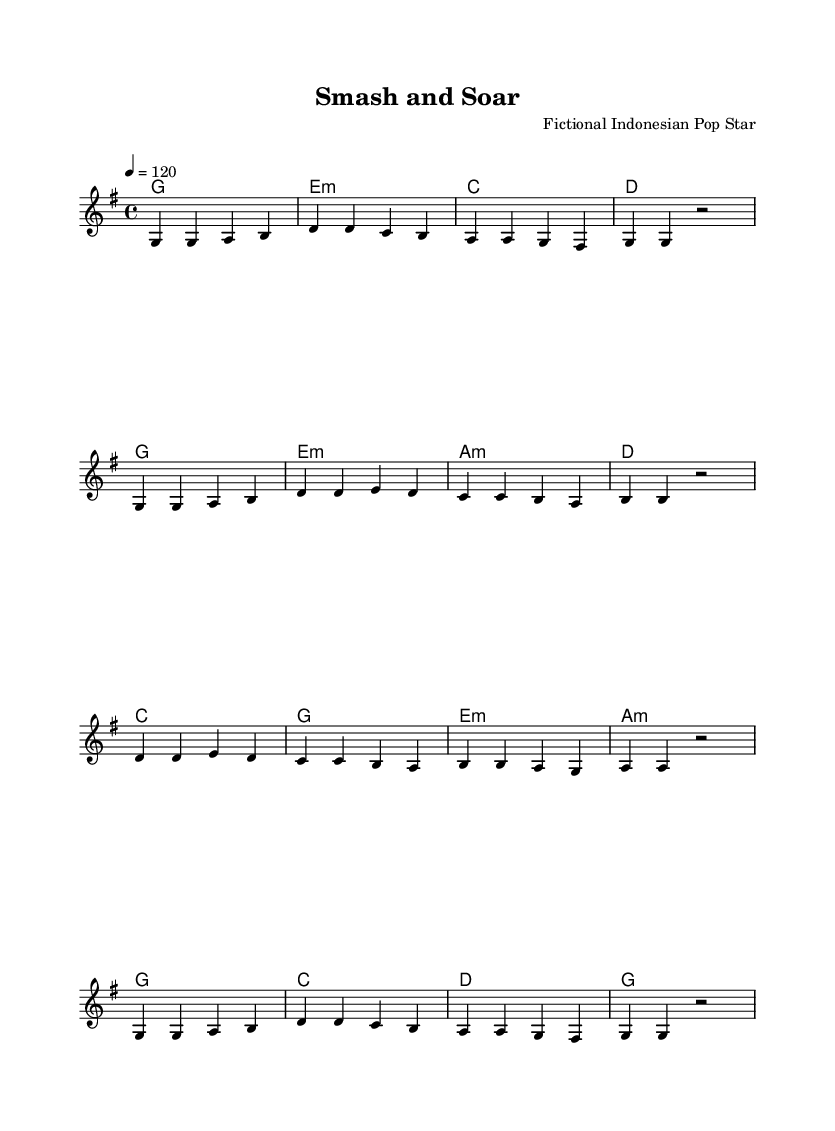What is the key signature of this music? The key signature is G major, which has one sharp (F#). This is determined by looking at the key signature indicated at the beginning of the sheet music.
Answer: G major What is the time signature of this music? The time signature is 4/4, as noted at the beginning of the sheet music right next to the key signature. This means there are four beats in each measure, and the quarter note gets one beat.
Answer: 4/4 What is the tempo of this piece? The tempo is 120 beats per minute, indicated at the beginning of the score under the global settings for tempo. This means the piece is intended to be played at a moderate speed.
Answer: 120 How many measures are in the melody? There are 12 measures in the melody section of the sheet music. This can be counted by looking at the grouping of notes and spaces, where each measure is separated by a vertical line.
Answer: 12 What chord is played in the first measure? The chord played in the first measure is G major, noted at the beginning of the chord progressions in the score. This can be identified by the chord name listed above the measures.
Answer: G major What is the structure of the melody (e.g., repeating motifs, phrases)? The melody has a repeating structure, with phrases that often mirror each other, resulting in a symmetric pattern throughout the piece. This is indicated by the similar sequences of notes in different measures.
Answer: Repeating structure 